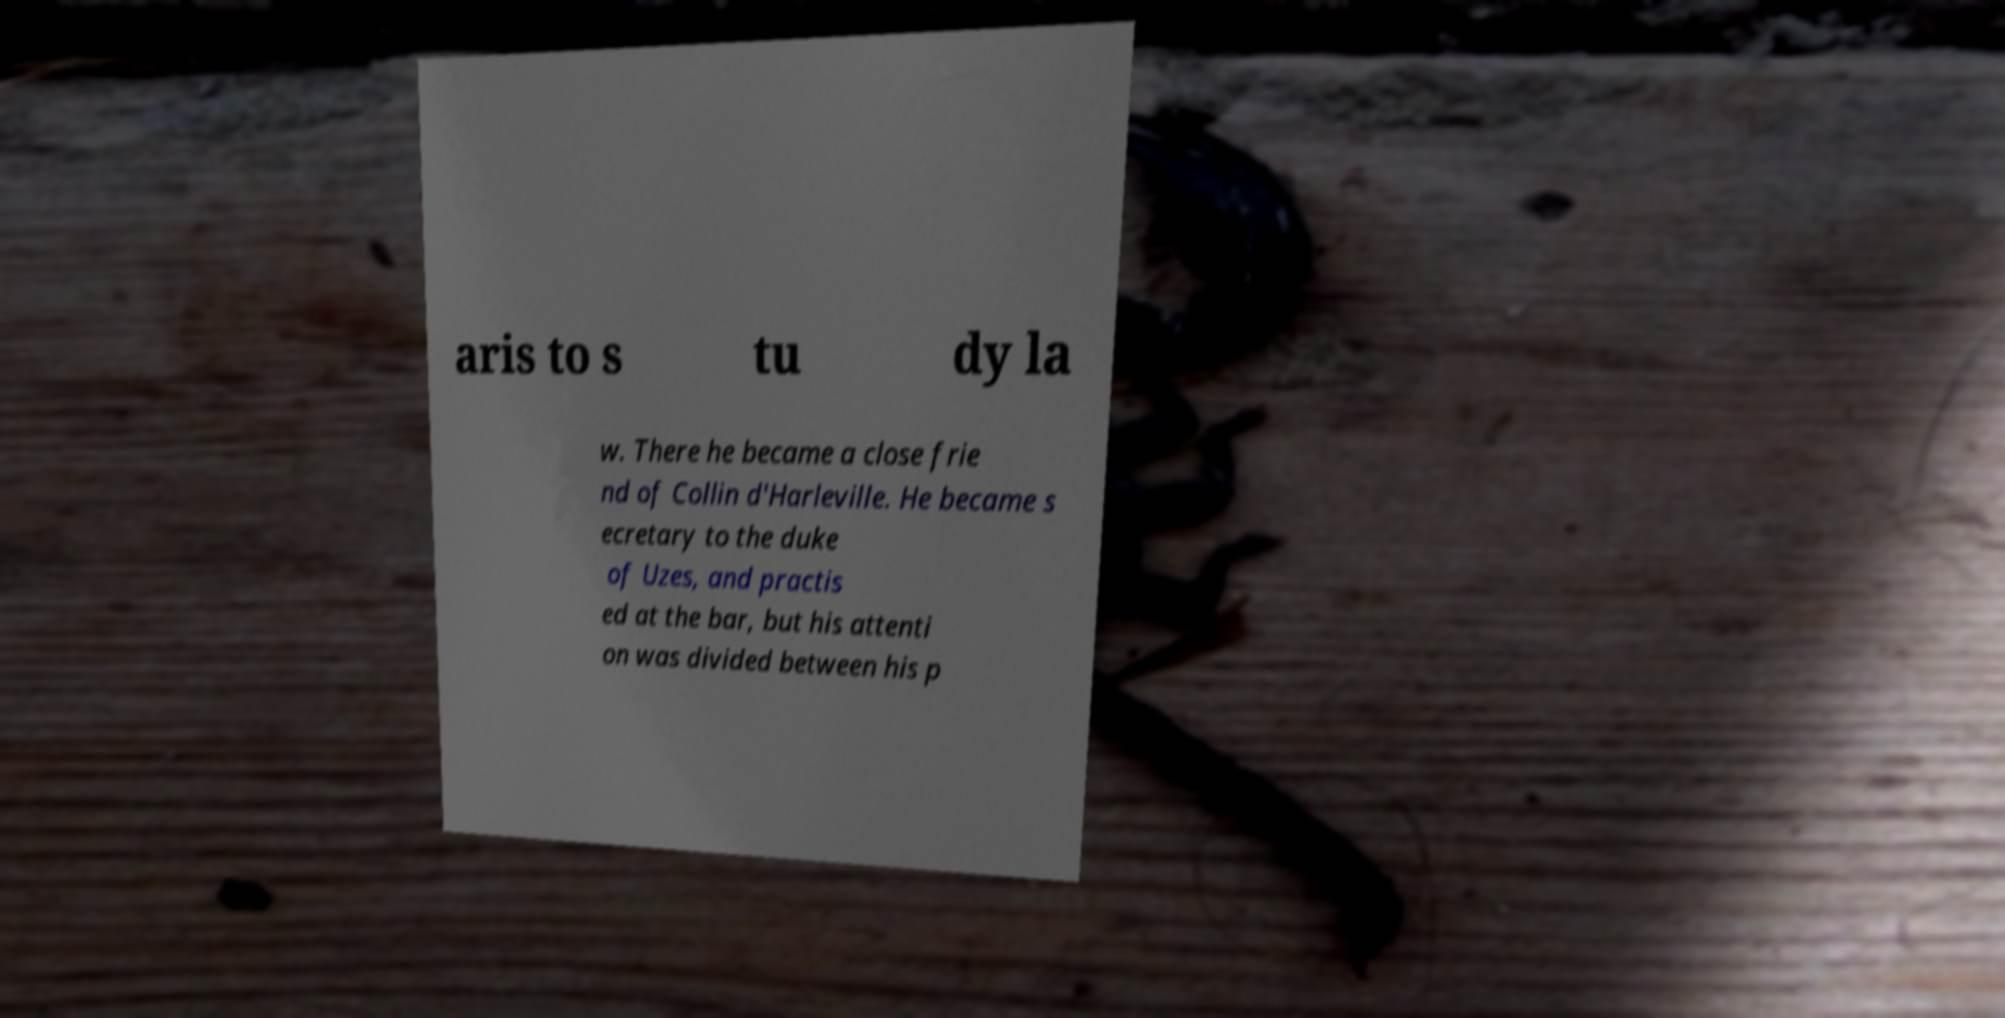Could you extract and type out the text from this image? aris to s tu dy la w. There he became a close frie nd of Collin d'Harleville. He became s ecretary to the duke of Uzes, and practis ed at the bar, but his attenti on was divided between his p 